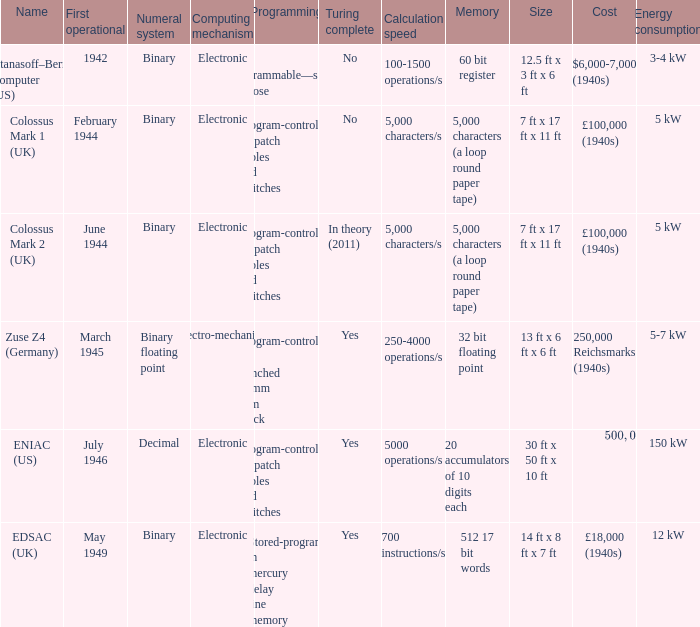What's the first operational with programming being not programmable—single purpose 1942.0. 